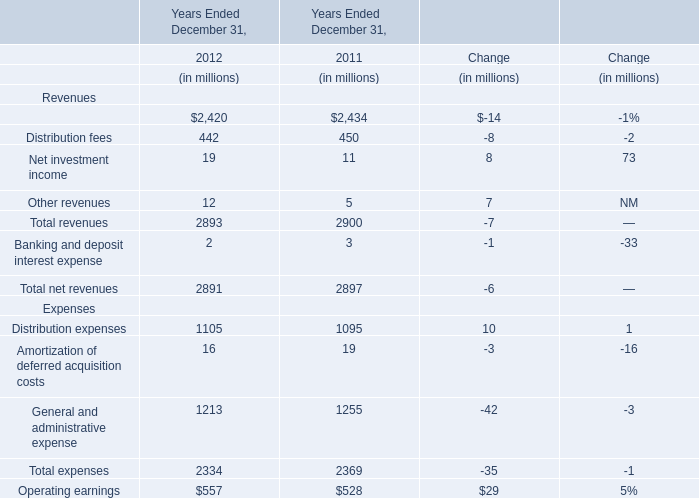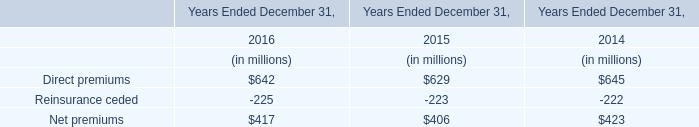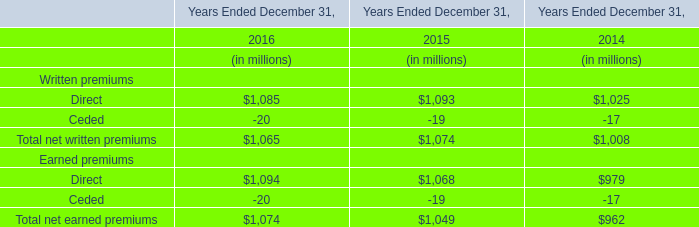What's the average of the Distribution fees and Net investment income in the years where Management and financial advice fees is positive? (in million) 
Computations: ((450 + 11) / 2)
Answer: 230.5. 